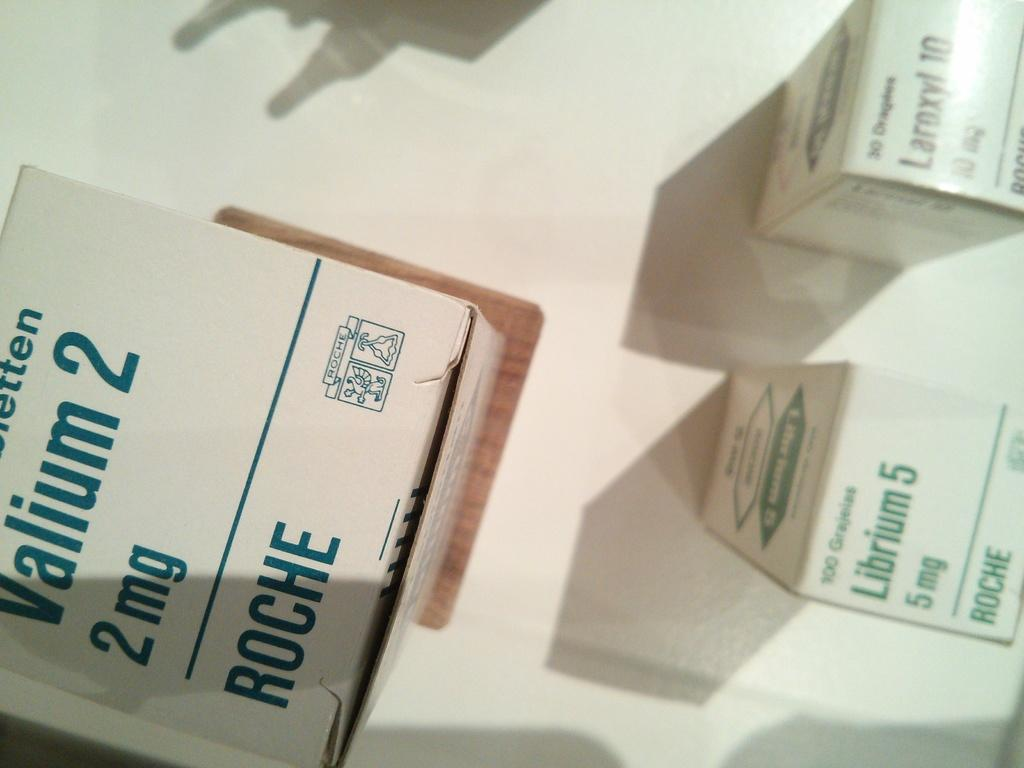<image>
Present a compact description of the photo's key features. many boxes of Roche for Valium 2 and Librium 5 